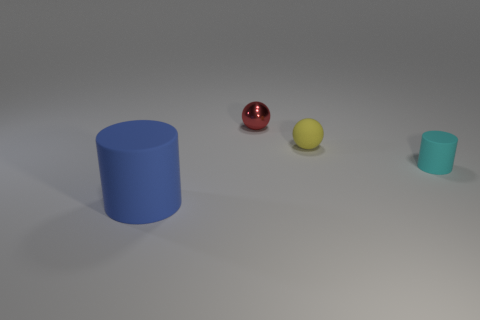Add 1 tiny cyan objects. How many objects exist? 5 Subtract 2 spheres. How many spheres are left? 0 Subtract 0 yellow cubes. How many objects are left? 4 Subtract all blue cylinders. Subtract all yellow balls. How many cylinders are left? 1 Subtract all matte objects. Subtract all small cyan rubber objects. How many objects are left? 0 Add 3 small metallic objects. How many small metallic objects are left? 4 Add 3 small brown shiny balls. How many small brown shiny balls exist? 3 